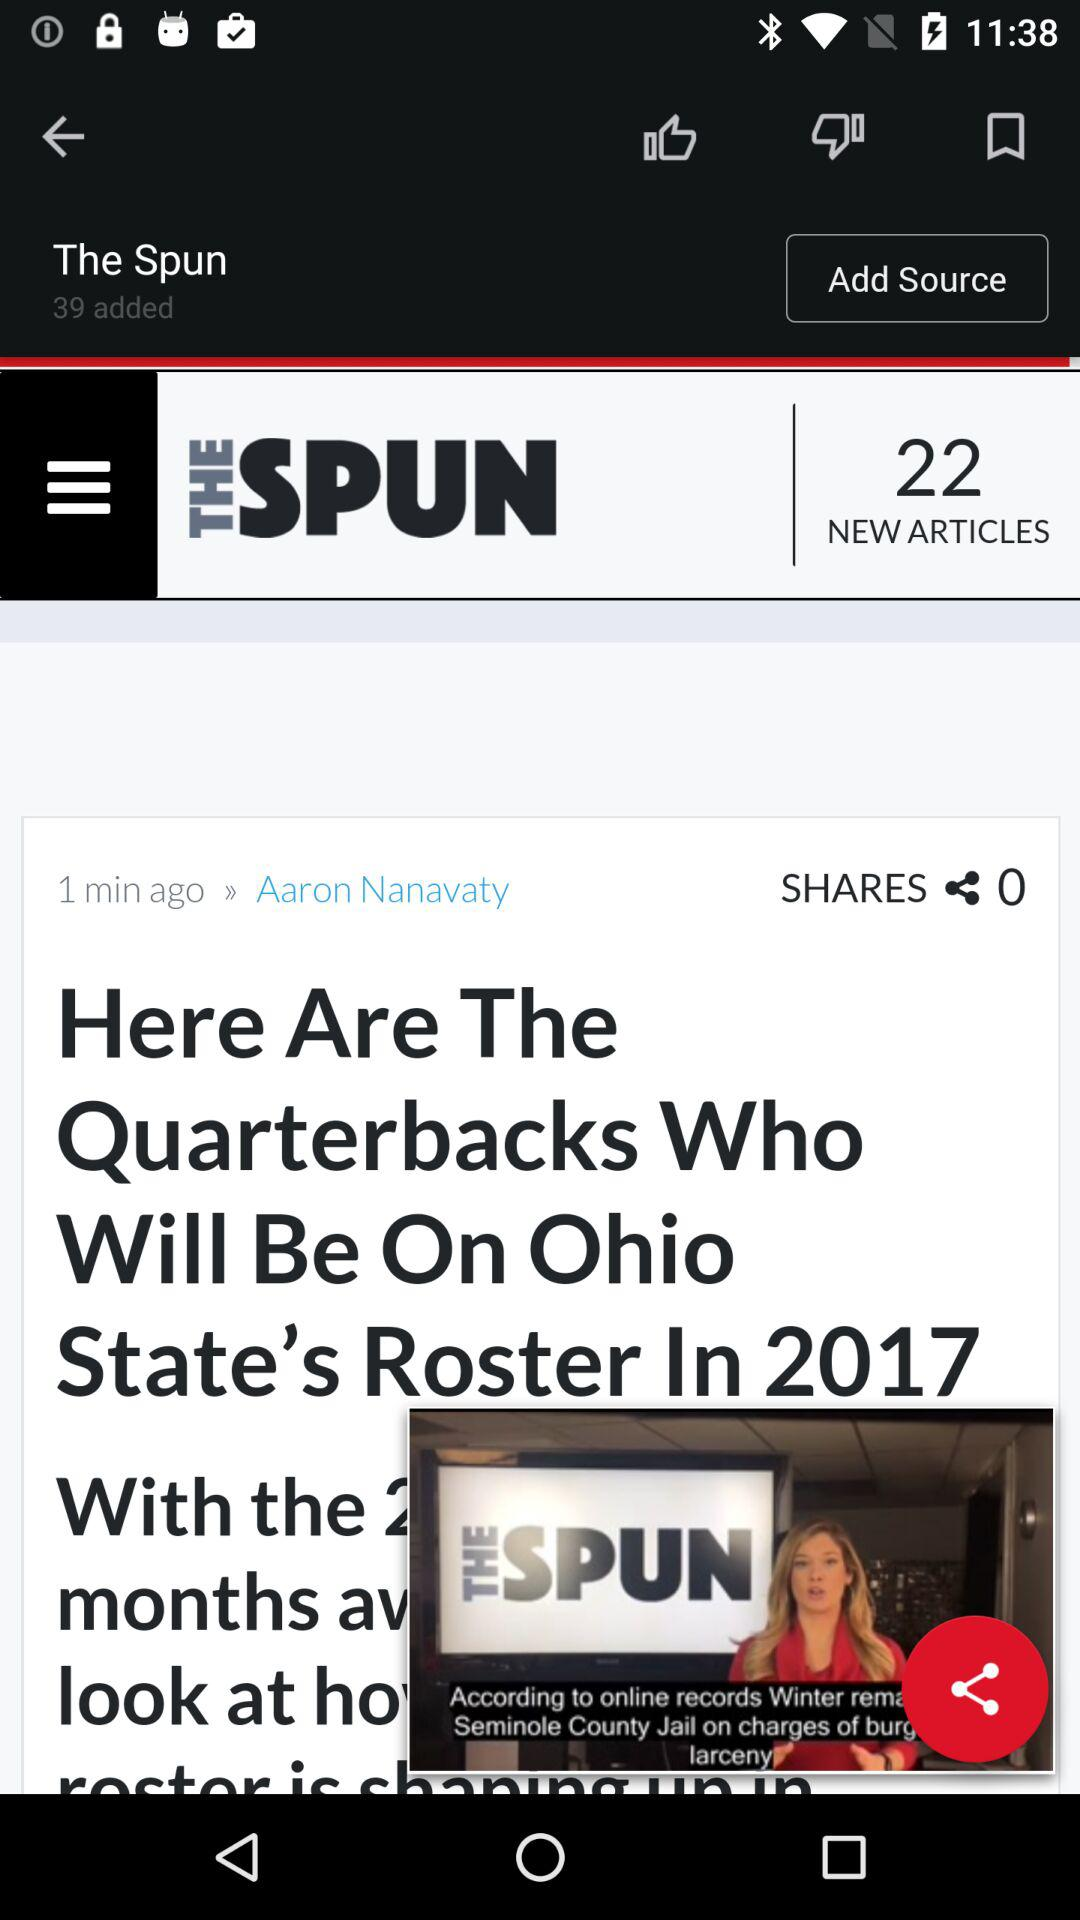How many more subscribers does The Spun have than the number of shares on the article?
Answer the question using a single word or phrase. 39 